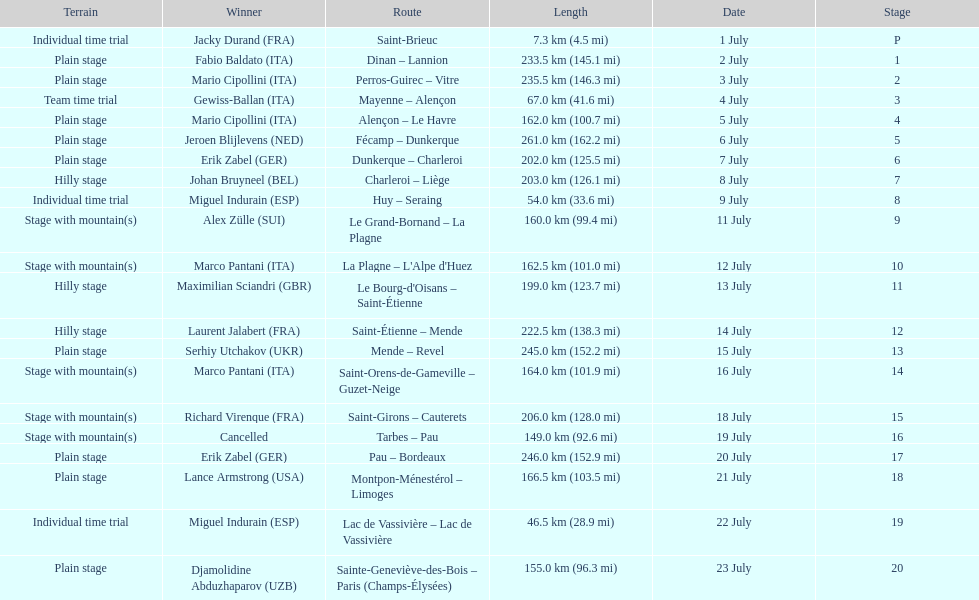How many stages were at least 200 km in length in the 1995 tour de france? 9. 